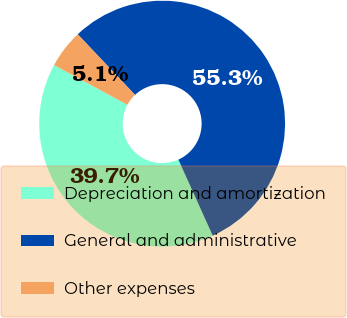Convert chart. <chart><loc_0><loc_0><loc_500><loc_500><pie_chart><fcel>Depreciation and amortization<fcel>General and administrative<fcel>Other expenses<nl><fcel>39.65%<fcel>55.3%<fcel>5.05%<nl></chart> 